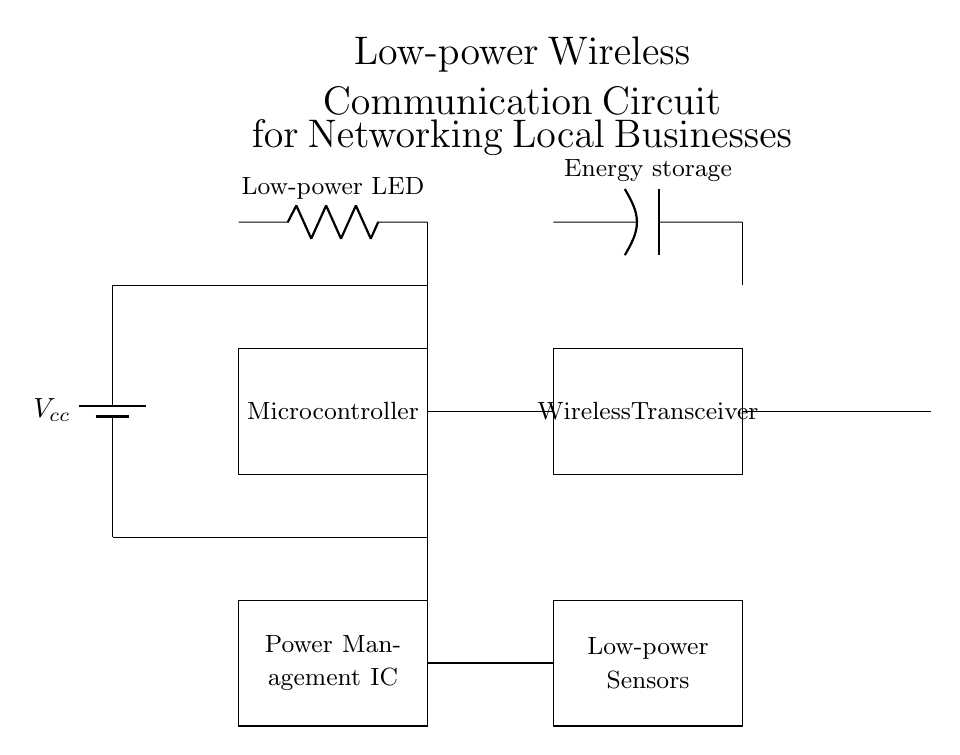What components are present in the circuit? The circuit includes a battery, microcontroller, wireless transceiver, antenna, a low-power LED, energy storage, a power management IC, and low-power sensors. These components serve different roles in creating a low-power wireless communication system.
Answer: battery, microcontroller, wireless transceiver, antenna, low-power LED, energy storage, power management IC, low-power sensors What is the function of the microcontroller in this circuit? The microcontroller is responsible for processing signals and controlling the communication between different components in the circuit. It manages the interactions between the sensors, transceiver, and power management unit, enabling data exchange over the network.
Answer: signal processing and control What type of power supply is used in this circuit? The circuit uses a battery as the power source, indicated by the symbol in the diagram. This implies that the circuit is designed for portability and low power consumption specific to its application.
Answer: battery How do the sensors connect to the microcontroller? The sensors connect directly to the microcontroller through a wire connection. This setup allows for the sensors to send collected data to the microcontroller for processing and communication purposes.
Answer: direct wire connection What is the purpose of the antenna in this circuit? The antenna is used to transmit and receive wireless signals, facilitating communication between local businesses and organizations. This component is crucial for enabling wireless networking functionality in the circuit.
Answer: transmit and receive signals How is energy managed in this circuit? Energy management is handled by the Power Management IC, which regulates the voltage and current provided to the various components, ensuring efficient use of power while maintaining functionality in a low-power setup.
Answer: Power Management IC What type of LED is used in the circuit? The circuit utilizes a low-power LED, which indicates that energy efficiency is a priority, making it suitable for applications where power consumption needs to be minimized.
Answer: low-power LED 